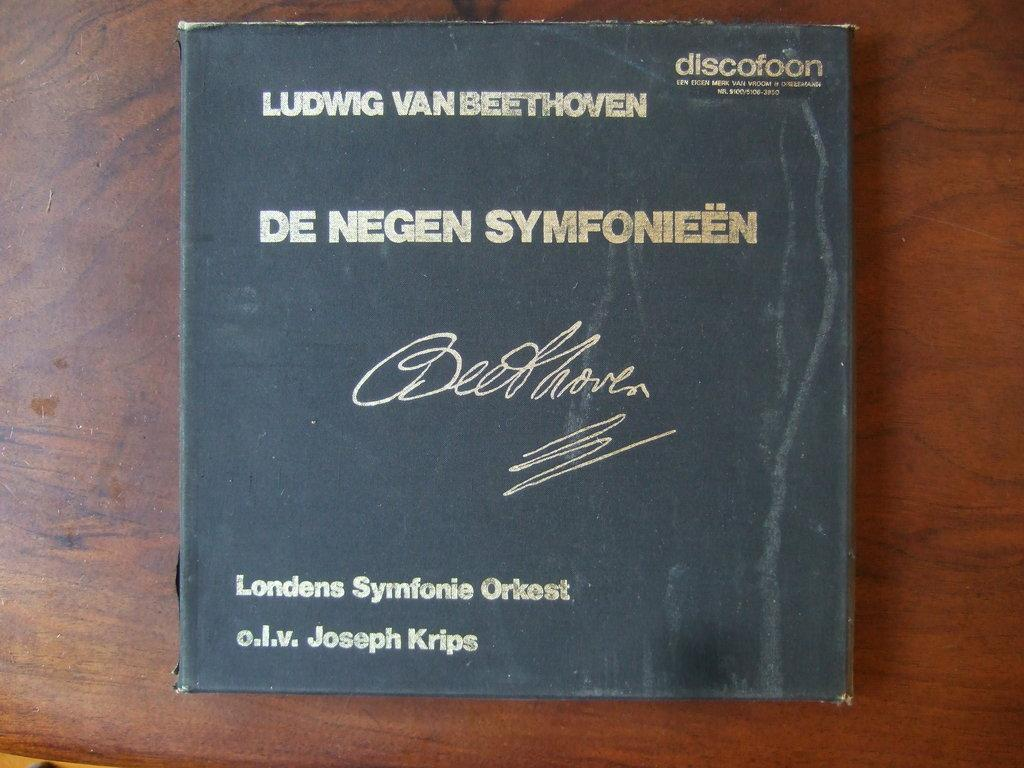<image>
Summarize the visual content of the image. Ludwig Van Beethoven De Negen Symfonieen discofoon cover. 